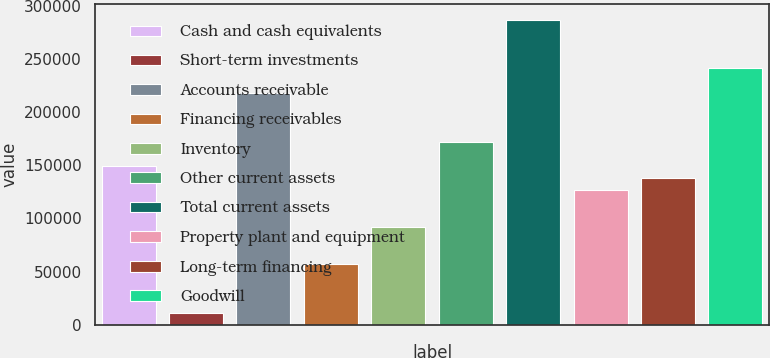Convert chart. <chart><loc_0><loc_0><loc_500><loc_500><bar_chart><fcel>Cash and cash equivalents<fcel>Short-term investments<fcel>Accounts receivable<fcel>Financing receivables<fcel>Inventory<fcel>Other current assets<fcel>Total current assets<fcel>Property plant and equipment<fcel>Long-term financing<fcel>Goodwill<nl><fcel>149232<fcel>11501.5<fcel>218096<fcel>57411.5<fcel>91844<fcel>172186<fcel>286962<fcel>126276<fcel>137754<fcel>241052<nl></chart> 